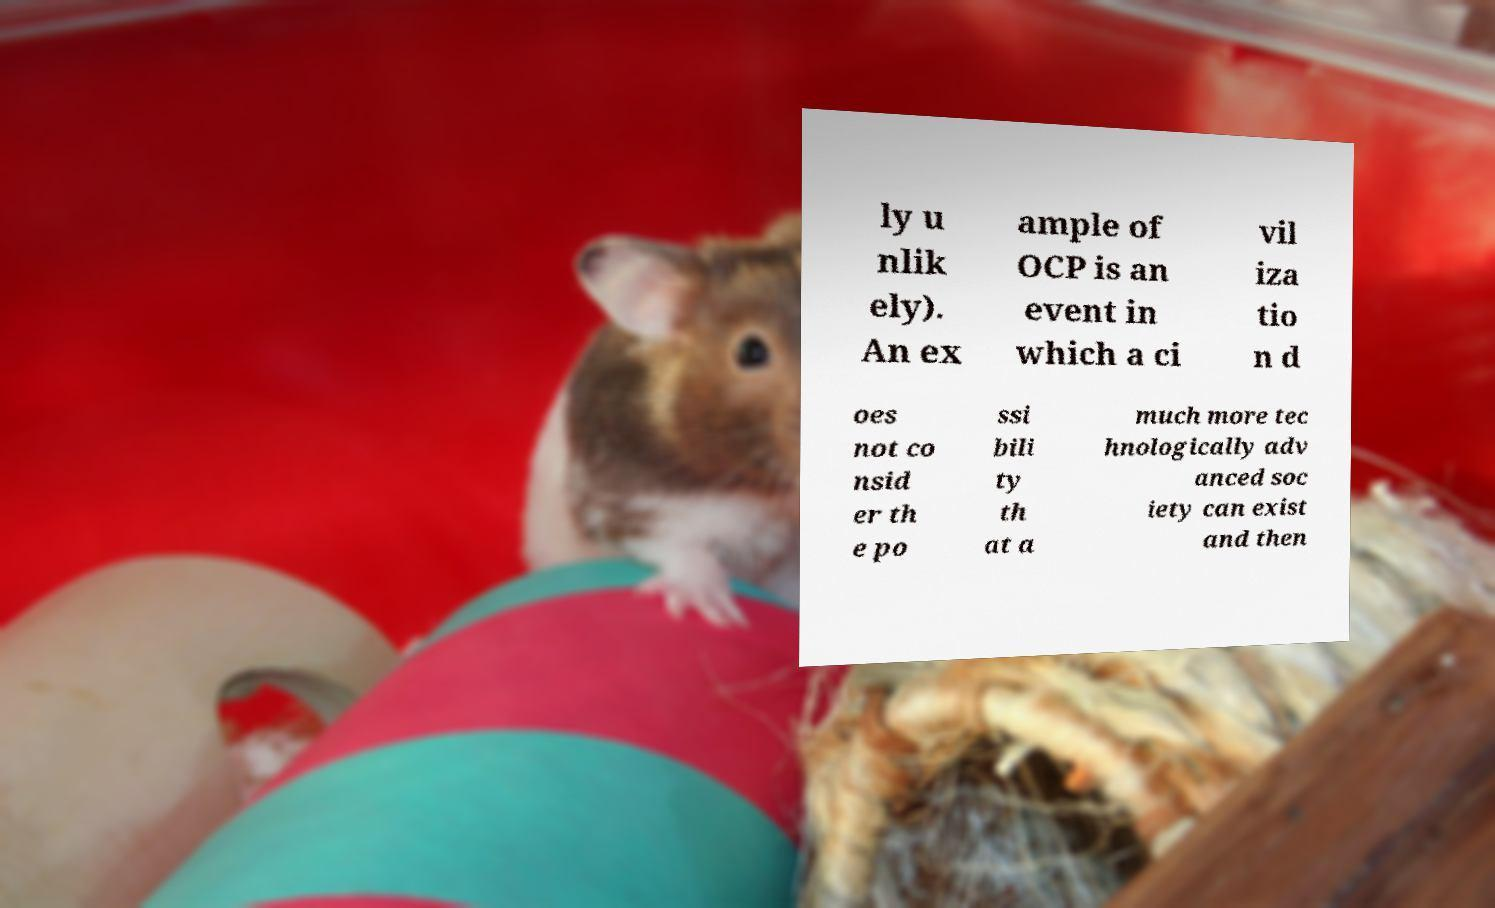Please identify and transcribe the text found in this image. ly u nlik ely). An ex ample of OCP is an event in which a ci vil iza tio n d oes not co nsid er th e po ssi bili ty th at a much more tec hnologically adv anced soc iety can exist and then 